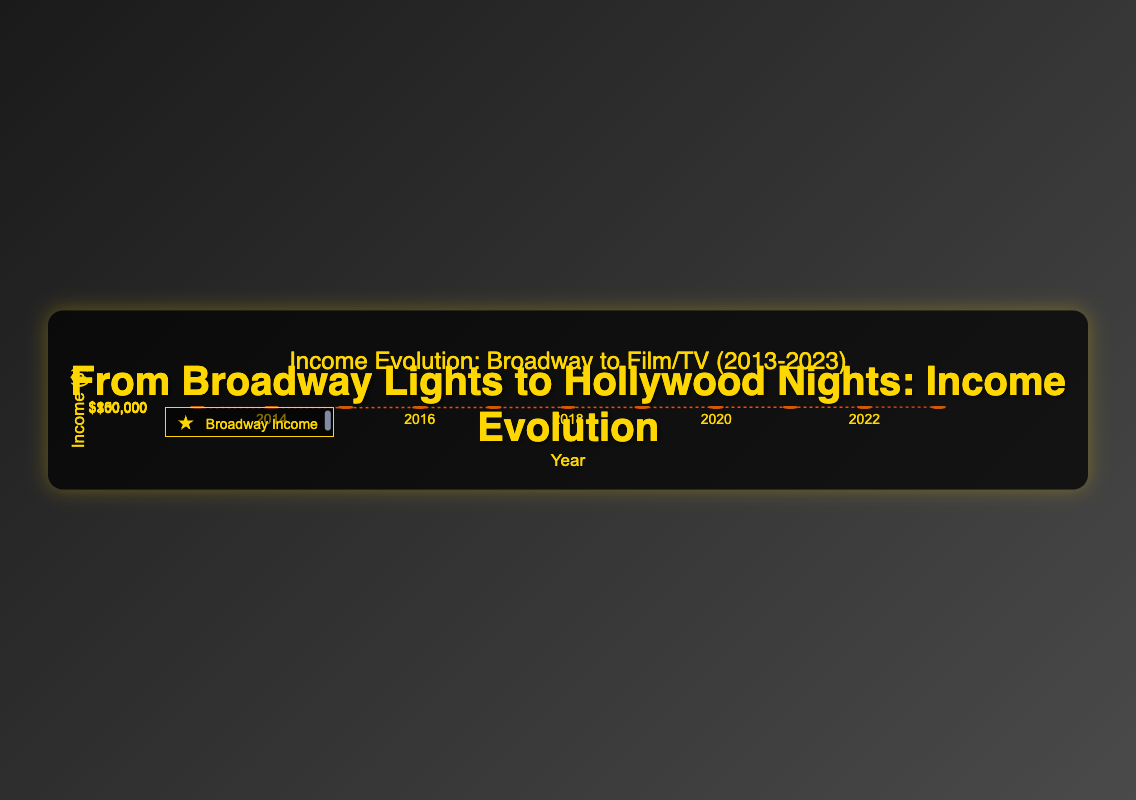What is the title of the figure? The title is prominently displayed at the top of the figure in large, bold text. The title reads, "Income Evolution: Broadway to Film/TV (2013-2023)."
Answer: Income Evolution: Broadway to Film/TV (2013-2023) How many data points are displayed in the figure for each income type? By counting the number of markers representing Broadway income and Film/TV income, there are 11 data points for each type.
Answer: 11 What color represents Broadway income in the scatter plot? The Broadway income points are depicted in a gold color.
Answer: gold What is the overall trend observed in the Film/TV income from 2013 to 2023? Observing the trendline and the progressive increase in the height of the markers, the Film/TV income shows a noticeable upward trend from 2013 to 2023.
Answer: increasing What is the difference between the highest initial Broadway income and the highest first-year Film/TV income in 2023? The highest initial Broadway income is $95,000 (in 2022 and 2023), and the highest first-year Film/TV income is $200,000 (in 2023). The difference is $200,000 - $95,000 = $105,000.
Answer: $105,000 In which year did actors experience the largest increase in income when transitioning from Broadway to Film/TV? Reviewing the data points, 2023 shows the largest difference with an initial Broadway income of $95,000 and a first-year Film/TV income of $200,000, resulting in a $105,000 increase.
Answer: 2023 Is there any year in which the Broadway income is greater than the Film/TV income? Observing the scatter plot, there is no year where the Broadway income is greater than the Film/TV income; the Film/TV income is always higher.
Answer: no Which year had the highest first-year Film/TV income, and what was the amount? By observing the scatter plot, the highest first-year Film/TV income occurs in 2023, which is $200,000.
Answer: 2023, $200,000 What is the average first-year Film/TV income for the given years? Calculate the sum of the Film/TV incomes and divide by the number of years: (100000 + 110000 + 120000 + 130000 + 140000 + 150000 + 160000 + 170000 + 180000 + 190000 + 200000) / 11 = $145,454.54
Answer: $145,454.54 